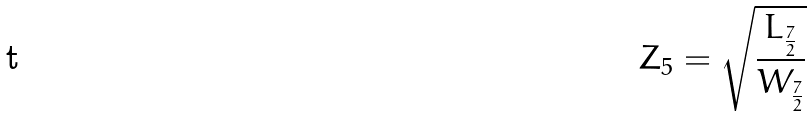<formula> <loc_0><loc_0><loc_500><loc_500>Z _ { 5 } = \sqrt { \frac { L _ { \frac { 7 } { 2 } } } { W _ { \frac { 7 } { 2 } } } }</formula> 